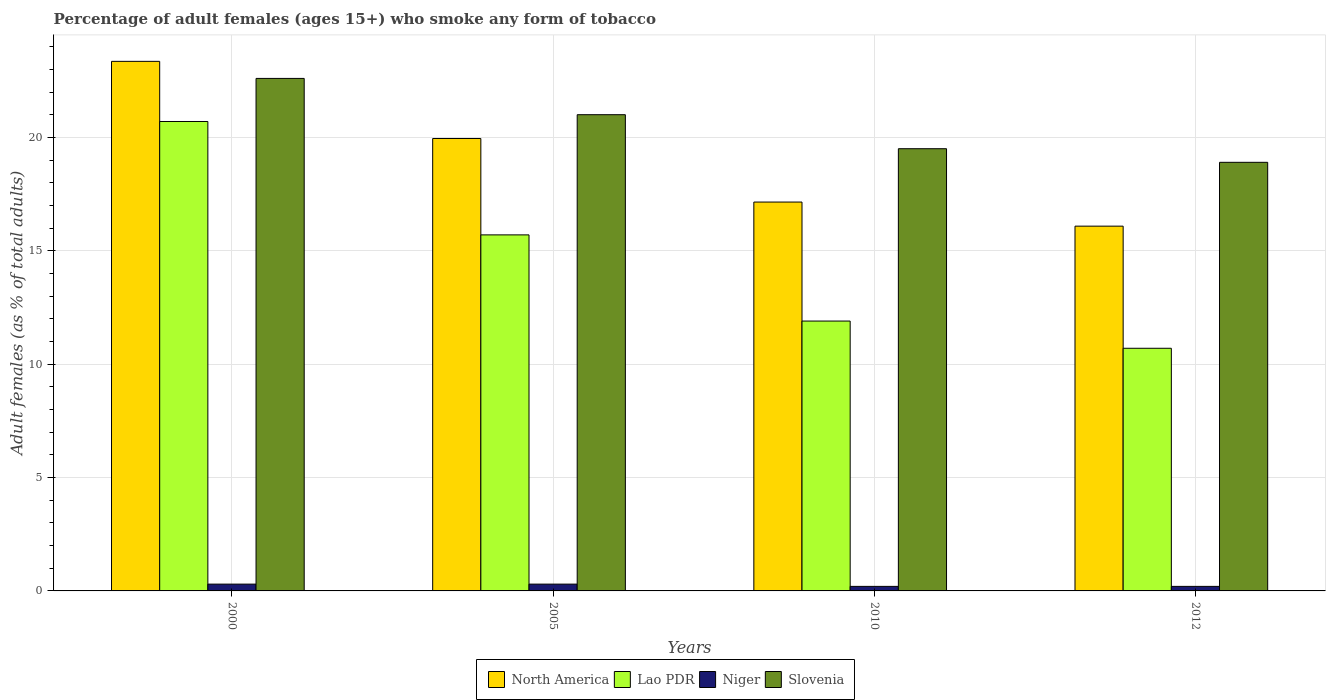How many groups of bars are there?
Your answer should be very brief. 4. How many bars are there on the 1st tick from the left?
Make the answer very short. 4. How many bars are there on the 2nd tick from the right?
Keep it short and to the point. 4. What is the label of the 1st group of bars from the left?
Give a very brief answer. 2000. What is the percentage of adult females who smoke in Lao PDR in 2012?
Provide a short and direct response. 10.7. Across all years, what is the maximum percentage of adult females who smoke in Slovenia?
Your answer should be compact. 22.6. Across all years, what is the minimum percentage of adult females who smoke in North America?
Your response must be concise. 16.09. In which year was the percentage of adult females who smoke in Niger maximum?
Make the answer very short. 2000. In which year was the percentage of adult females who smoke in Niger minimum?
Make the answer very short. 2010. What is the total percentage of adult females who smoke in North America in the graph?
Keep it short and to the point. 76.54. What is the difference between the percentage of adult females who smoke in North America in 2000 and that in 2010?
Provide a short and direct response. 6.2. What is the difference between the percentage of adult females who smoke in Slovenia in 2005 and the percentage of adult females who smoke in Niger in 2012?
Provide a short and direct response. 20.8. In the year 2012, what is the difference between the percentage of adult females who smoke in Slovenia and percentage of adult females who smoke in North America?
Your answer should be compact. 2.81. What is the ratio of the percentage of adult females who smoke in North America in 2005 to that in 2010?
Your answer should be very brief. 1.16. What is the difference between the highest and the second highest percentage of adult females who smoke in Slovenia?
Your answer should be compact. 1.6. What is the difference between the highest and the lowest percentage of adult females who smoke in Slovenia?
Offer a very short reply. 3.7. Is the sum of the percentage of adult females who smoke in Slovenia in 2010 and 2012 greater than the maximum percentage of adult females who smoke in Lao PDR across all years?
Ensure brevity in your answer.  Yes. What does the 3rd bar from the left in 2010 represents?
Offer a terse response. Niger. What does the 3rd bar from the right in 2012 represents?
Your answer should be compact. Lao PDR. Is it the case that in every year, the sum of the percentage of adult females who smoke in Niger and percentage of adult females who smoke in North America is greater than the percentage of adult females who smoke in Slovenia?
Offer a very short reply. No. Are all the bars in the graph horizontal?
Offer a very short reply. No. How many years are there in the graph?
Give a very brief answer. 4. What is the difference between two consecutive major ticks on the Y-axis?
Your answer should be compact. 5. Are the values on the major ticks of Y-axis written in scientific E-notation?
Your response must be concise. No. Does the graph contain any zero values?
Your answer should be compact. No. Does the graph contain grids?
Give a very brief answer. Yes. What is the title of the graph?
Your response must be concise. Percentage of adult females (ages 15+) who smoke any form of tobacco. What is the label or title of the Y-axis?
Your answer should be compact. Adult females (as % of total adults). What is the Adult females (as % of total adults) of North America in 2000?
Provide a short and direct response. 23.35. What is the Adult females (as % of total adults) in Lao PDR in 2000?
Your response must be concise. 20.7. What is the Adult females (as % of total adults) of Niger in 2000?
Provide a short and direct response. 0.3. What is the Adult females (as % of total adults) of Slovenia in 2000?
Your response must be concise. 22.6. What is the Adult females (as % of total adults) of North America in 2005?
Provide a short and direct response. 19.95. What is the Adult females (as % of total adults) of Lao PDR in 2005?
Your answer should be compact. 15.7. What is the Adult females (as % of total adults) in Niger in 2005?
Provide a succinct answer. 0.3. What is the Adult females (as % of total adults) of North America in 2010?
Ensure brevity in your answer.  17.15. What is the Adult females (as % of total adults) of Slovenia in 2010?
Make the answer very short. 19.5. What is the Adult females (as % of total adults) of North America in 2012?
Give a very brief answer. 16.09. What is the Adult females (as % of total adults) in Lao PDR in 2012?
Keep it short and to the point. 10.7. Across all years, what is the maximum Adult females (as % of total adults) in North America?
Your response must be concise. 23.35. Across all years, what is the maximum Adult females (as % of total adults) in Lao PDR?
Your answer should be compact. 20.7. Across all years, what is the maximum Adult females (as % of total adults) in Slovenia?
Provide a short and direct response. 22.6. Across all years, what is the minimum Adult females (as % of total adults) in North America?
Give a very brief answer. 16.09. Across all years, what is the minimum Adult females (as % of total adults) in Lao PDR?
Offer a terse response. 10.7. Across all years, what is the minimum Adult females (as % of total adults) in Niger?
Your answer should be compact. 0.2. Across all years, what is the minimum Adult females (as % of total adults) of Slovenia?
Your answer should be compact. 18.9. What is the total Adult females (as % of total adults) in North America in the graph?
Provide a succinct answer. 76.54. What is the total Adult females (as % of total adults) of Slovenia in the graph?
Give a very brief answer. 82. What is the difference between the Adult females (as % of total adults) of North America in 2000 and that in 2005?
Your answer should be very brief. 3.4. What is the difference between the Adult females (as % of total adults) of Lao PDR in 2000 and that in 2005?
Provide a succinct answer. 5. What is the difference between the Adult females (as % of total adults) in North America in 2000 and that in 2010?
Your answer should be very brief. 6.2. What is the difference between the Adult females (as % of total adults) of Slovenia in 2000 and that in 2010?
Ensure brevity in your answer.  3.1. What is the difference between the Adult females (as % of total adults) in North America in 2000 and that in 2012?
Ensure brevity in your answer.  7.27. What is the difference between the Adult females (as % of total adults) of Lao PDR in 2000 and that in 2012?
Provide a succinct answer. 10. What is the difference between the Adult females (as % of total adults) in North America in 2005 and that in 2010?
Ensure brevity in your answer.  2.8. What is the difference between the Adult females (as % of total adults) in Slovenia in 2005 and that in 2010?
Provide a succinct answer. 1.5. What is the difference between the Adult females (as % of total adults) of North America in 2005 and that in 2012?
Offer a very short reply. 3.86. What is the difference between the Adult females (as % of total adults) of Lao PDR in 2005 and that in 2012?
Provide a succinct answer. 5. What is the difference between the Adult females (as % of total adults) of North America in 2010 and that in 2012?
Give a very brief answer. 1.06. What is the difference between the Adult females (as % of total adults) of Lao PDR in 2010 and that in 2012?
Keep it short and to the point. 1.2. What is the difference between the Adult females (as % of total adults) in Slovenia in 2010 and that in 2012?
Your response must be concise. 0.6. What is the difference between the Adult females (as % of total adults) in North America in 2000 and the Adult females (as % of total adults) in Lao PDR in 2005?
Keep it short and to the point. 7.65. What is the difference between the Adult females (as % of total adults) in North America in 2000 and the Adult females (as % of total adults) in Niger in 2005?
Offer a very short reply. 23.05. What is the difference between the Adult females (as % of total adults) in North America in 2000 and the Adult females (as % of total adults) in Slovenia in 2005?
Provide a short and direct response. 2.35. What is the difference between the Adult females (as % of total adults) in Lao PDR in 2000 and the Adult females (as % of total adults) in Niger in 2005?
Make the answer very short. 20.4. What is the difference between the Adult females (as % of total adults) of Lao PDR in 2000 and the Adult females (as % of total adults) of Slovenia in 2005?
Your answer should be very brief. -0.3. What is the difference between the Adult females (as % of total adults) in Niger in 2000 and the Adult females (as % of total adults) in Slovenia in 2005?
Make the answer very short. -20.7. What is the difference between the Adult females (as % of total adults) of North America in 2000 and the Adult females (as % of total adults) of Lao PDR in 2010?
Your response must be concise. 11.45. What is the difference between the Adult females (as % of total adults) of North America in 2000 and the Adult females (as % of total adults) of Niger in 2010?
Your answer should be very brief. 23.15. What is the difference between the Adult females (as % of total adults) of North America in 2000 and the Adult females (as % of total adults) of Slovenia in 2010?
Offer a terse response. 3.85. What is the difference between the Adult females (as % of total adults) of Lao PDR in 2000 and the Adult females (as % of total adults) of Slovenia in 2010?
Your answer should be compact. 1.2. What is the difference between the Adult females (as % of total adults) of Niger in 2000 and the Adult females (as % of total adults) of Slovenia in 2010?
Give a very brief answer. -19.2. What is the difference between the Adult females (as % of total adults) in North America in 2000 and the Adult females (as % of total adults) in Lao PDR in 2012?
Keep it short and to the point. 12.65. What is the difference between the Adult females (as % of total adults) of North America in 2000 and the Adult females (as % of total adults) of Niger in 2012?
Offer a terse response. 23.15. What is the difference between the Adult females (as % of total adults) of North America in 2000 and the Adult females (as % of total adults) of Slovenia in 2012?
Provide a short and direct response. 4.45. What is the difference between the Adult females (as % of total adults) in Lao PDR in 2000 and the Adult females (as % of total adults) in Niger in 2012?
Your answer should be compact. 20.5. What is the difference between the Adult females (as % of total adults) of Lao PDR in 2000 and the Adult females (as % of total adults) of Slovenia in 2012?
Your answer should be very brief. 1.8. What is the difference between the Adult females (as % of total adults) in Niger in 2000 and the Adult females (as % of total adults) in Slovenia in 2012?
Your response must be concise. -18.6. What is the difference between the Adult females (as % of total adults) in North America in 2005 and the Adult females (as % of total adults) in Lao PDR in 2010?
Offer a terse response. 8.05. What is the difference between the Adult females (as % of total adults) of North America in 2005 and the Adult females (as % of total adults) of Niger in 2010?
Provide a succinct answer. 19.75. What is the difference between the Adult females (as % of total adults) in North America in 2005 and the Adult females (as % of total adults) in Slovenia in 2010?
Your answer should be compact. 0.45. What is the difference between the Adult females (as % of total adults) of Lao PDR in 2005 and the Adult females (as % of total adults) of Niger in 2010?
Your response must be concise. 15.5. What is the difference between the Adult females (as % of total adults) of Niger in 2005 and the Adult females (as % of total adults) of Slovenia in 2010?
Keep it short and to the point. -19.2. What is the difference between the Adult females (as % of total adults) of North America in 2005 and the Adult females (as % of total adults) of Lao PDR in 2012?
Provide a short and direct response. 9.25. What is the difference between the Adult females (as % of total adults) in North America in 2005 and the Adult females (as % of total adults) in Niger in 2012?
Give a very brief answer. 19.75. What is the difference between the Adult females (as % of total adults) of North America in 2005 and the Adult females (as % of total adults) of Slovenia in 2012?
Offer a very short reply. 1.05. What is the difference between the Adult females (as % of total adults) in Lao PDR in 2005 and the Adult females (as % of total adults) in Niger in 2012?
Make the answer very short. 15.5. What is the difference between the Adult females (as % of total adults) of Lao PDR in 2005 and the Adult females (as % of total adults) of Slovenia in 2012?
Keep it short and to the point. -3.2. What is the difference between the Adult females (as % of total adults) of Niger in 2005 and the Adult females (as % of total adults) of Slovenia in 2012?
Your answer should be compact. -18.6. What is the difference between the Adult females (as % of total adults) of North America in 2010 and the Adult females (as % of total adults) of Lao PDR in 2012?
Provide a short and direct response. 6.45. What is the difference between the Adult females (as % of total adults) in North America in 2010 and the Adult females (as % of total adults) in Niger in 2012?
Give a very brief answer. 16.95. What is the difference between the Adult females (as % of total adults) of North America in 2010 and the Adult females (as % of total adults) of Slovenia in 2012?
Your answer should be compact. -1.75. What is the difference between the Adult females (as % of total adults) in Lao PDR in 2010 and the Adult females (as % of total adults) in Slovenia in 2012?
Make the answer very short. -7. What is the difference between the Adult females (as % of total adults) of Niger in 2010 and the Adult females (as % of total adults) of Slovenia in 2012?
Offer a very short reply. -18.7. What is the average Adult females (as % of total adults) in North America per year?
Ensure brevity in your answer.  19.13. What is the average Adult females (as % of total adults) of Lao PDR per year?
Keep it short and to the point. 14.75. What is the average Adult females (as % of total adults) in Niger per year?
Your answer should be compact. 0.25. In the year 2000, what is the difference between the Adult females (as % of total adults) in North America and Adult females (as % of total adults) in Lao PDR?
Your answer should be compact. 2.65. In the year 2000, what is the difference between the Adult females (as % of total adults) in North America and Adult females (as % of total adults) in Niger?
Offer a very short reply. 23.05. In the year 2000, what is the difference between the Adult females (as % of total adults) of North America and Adult females (as % of total adults) of Slovenia?
Your answer should be compact. 0.75. In the year 2000, what is the difference between the Adult females (as % of total adults) in Lao PDR and Adult females (as % of total adults) in Niger?
Your answer should be compact. 20.4. In the year 2000, what is the difference between the Adult females (as % of total adults) in Lao PDR and Adult females (as % of total adults) in Slovenia?
Make the answer very short. -1.9. In the year 2000, what is the difference between the Adult females (as % of total adults) in Niger and Adult females (as % of total adults) in Slovenia?
Provide a short and direct response. -22.3. In the year 2005, what is the difference between the Adult females (as % of total adults) in North America and Adult females (as % of total adults) in Lao PDR?
Make the answer very short. 4.25. In the year 2005, what is the difference between the Adult females (as % of total adults) in North America and Adult females (as % of total adults) in Niger?
Give a very brief answer. 19.65. In the year 2005, what is the difference between the Adult females (as % of total adults) in North America and Adult females (as % of total adults) in Slovenia?
Provide a succinct answer. -1.05. In the year 2005, what is the difference between the Adult females (as % of total adults) in Lao PDR and Adult females (as % of total adults) in Niger?
Your answer should be compact. 15.4. In the year 2005, what is the difference between the Adult females (as % of total adults) in Lao PDR and Adult females (as % of total adults) in Slovenia?
Your answer should be compact. -5.3. In the year 2005, what is the difference between the Adult females (as % of total adults) of Niger and Adult females (as % of total adults) of Slovenia?
Give a very brief answer. -20.7. In the year 2010, what is the difference between the Adult females (as % of total adults) of North America and Adult females (as % of total adults) of Lao PDR?
Your answer should be compact. 5.25. In the year 2010, what is the difference between the Adult females (as % of total adults) of North America and Adult females (as % of total adults) of Niger?
Give a very brief answer. 16.95. In the year 2010, what is the difference between the Adult females (as % of total adults) of North America and Adult females (as % of total adults) of Slovenia?
Ensure brevity in your answer.  -2.35. In the year 2010, what is the difference between the Adult females (as % of total adults) in Lao PDR and Adult females (as % of total adults) in Slovenia?
Your response must be concise. -7.6. In the year 2010, what is the difference between the Adult females (as % of total adults) in Niger and Adult females (as % of total adults) in Slovenia?
Make the answer very short. -19.3. In the year 2012, what is the difference between the Adult females (as % of total adults) in North America and Adult females (as % of total adults) in Lao PDR?
Ensure brevity in your answer.  5.39. In the year 2012, what is the difference between the Adult females (as % of total adults) of North America and Adult females (as % of total adults) of Niger?
Provide a succinct answer. 15.89. In the year 2012, what is the difference between the Adult females (as % of total adults) of North America and Adult females (as % of total adults) of Slovenia?
Your answer should be very brief. -2.81. In the year 2012, what is the difference between the Adult females (as % of total adults) of Lao PDR and Adult females (as % of total adults) of Slovenia?
Your response must be concise. -8.2. In the year 2012, what is the difference between the Adult females (as % of total adults) of Niger and Adult females (as % of total adults) of Slovenia?
Offer a very short reply. -18.7. What is the ratio of the Adult females (as % of total adults) of North America in 2000 to that in 2005?
Offer a very short reply. 1.17. What is the ratio of the Adult females (as % of total adults) of Lao PDR in 2000 to that in 2005?
Provide a succinct answer. 1.32. What is the ratio of the Adult females (as % of total adults) in Niger in 2000 to that in 2005?
Give a very brief answer. 1. What is the ratio of the Adult females (as % of total adults) in Slovenia in 2000 to that in 2005?
Provide a short and direct response. 1.08. What is the ratio of the Adult females (as % of total adults) of North America in 2000 to that in 2010?
Offer a very short reply. 1.36. What is the ratio of the Adult females (as % of total adults) in Lao PDR in 2000 to that in 2010?
Your answer should be compact. 1.74. What is the ratio of the Adult females (as % of total adults) of Niger in 2000 to that in 2010?
Offer a very short reply. 1.5. What is the ratio of the Adult females (as % of total adults) of Slovenia in 2000 to that in 2010?
Your response must be concise. 1.16. What is the ratio of the Adult females (as % of total adults) in North America in 2000 to that in 2012?
Offer a terse response. 1.45. What is the ratio of the Adult females (as % of total adults) of Lao PDR in 2000 to that in 2012?
Your answer should be compact. 1.93. What is the ratio of the Adult females (as % of total adults) of Slovenia in 2000 to that in 2012?
Your answer should be compact. 1.2. What is the ratio of the Adult females (as % of total adults) in North America in 2005 to that in 2010?
Make the answer very short. 1.16. What is the ratio of the Adult females (as % of total adults) in Lao PDR in 2005 to that in 2010?
Make the answer very short. 1.32. What is the ratio of the Adult females (as % of total adults) of Slovenia in 2005 to that in 2010?
Your response must be concise. 1.08. What is the ratio of the Adult females (as % of total adults) in North America in 2005 to that in 2012?
Make the answer very short. 1.24. What is the ratio of the Adult females (as % of total adults) in Lao PDR in 2005 to that in 2012?
Keep it short and to the point. 1.47. What is the ratio of the Adult females (as % of total adults) in Niger in 2005 to that in 2012?
Your answer should be very brief. 1.5. What is the ratio of the Adult females (as % of total adults) in Slovenia in 2005 to that in 2012?
Ensure brevity in your answer.  1.11. What is the ratio of the Adult females (as % of total adults) of North America in 2010 to that in 2012?
Ensure brevity in your answer.  1.07. What is the ratio of the Adult females (as % of total adults) in Lao PDR in 2010 to that in 2012?
Your answer should be compact. 1.11. What is the ratio of the Adult females (as % of total adults) in Niger in 2010 to that in 2012?
Your answer should be compact. 1. What is the ratio of the Adult females (as % of total adults) in Slovenia in 2010 to that in 2012?
Offer a very short reply. 1.03. What is the difference between the highest and the second highest Adult females (as % of total adults) in North America?
Your answer should be very brief. 3.4. What is the difference between the highest and the second highest Adult females (as % of total adults) in Niger?
Offer a terse response. 0. What is the difference between the highest and the lowest Adult females (as % of total adults) of North America?
Your answer should be compact. 7.27. What is the difference between the highest and the lowest Adult females (as % of total adults) of Lao PDR?
Provide a succinct answer. 10. What is the difference between the highest and the lowest Adult females (as % of total adults) of Niger?
Offer a very short reply. 0.1. What is the difference between the highest and the lowest Adult females (as % of total adults) of Slovenia?
Give a very brief answer. 3.7. 